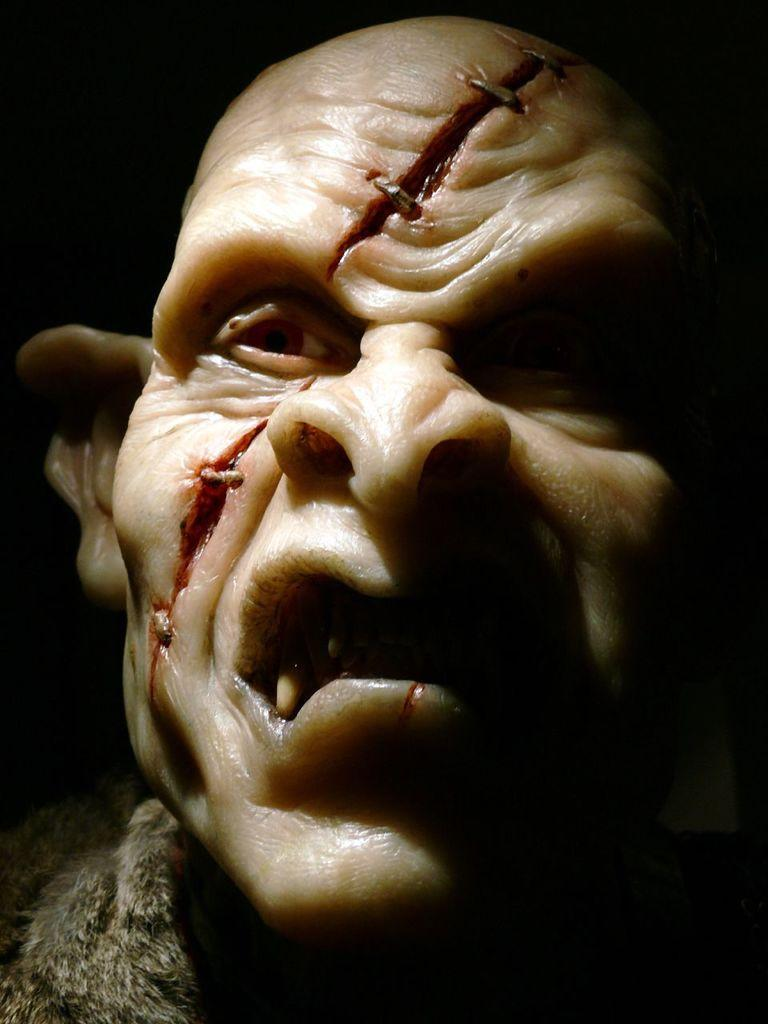What is the main object in the image? There is a mask-like object in the image. What color is the background of the image? The background of the image is black. What type of brass instrument is being played in the scene? There is no brass instrument or scene present in the image; it only features a mask-like object against a black background. 